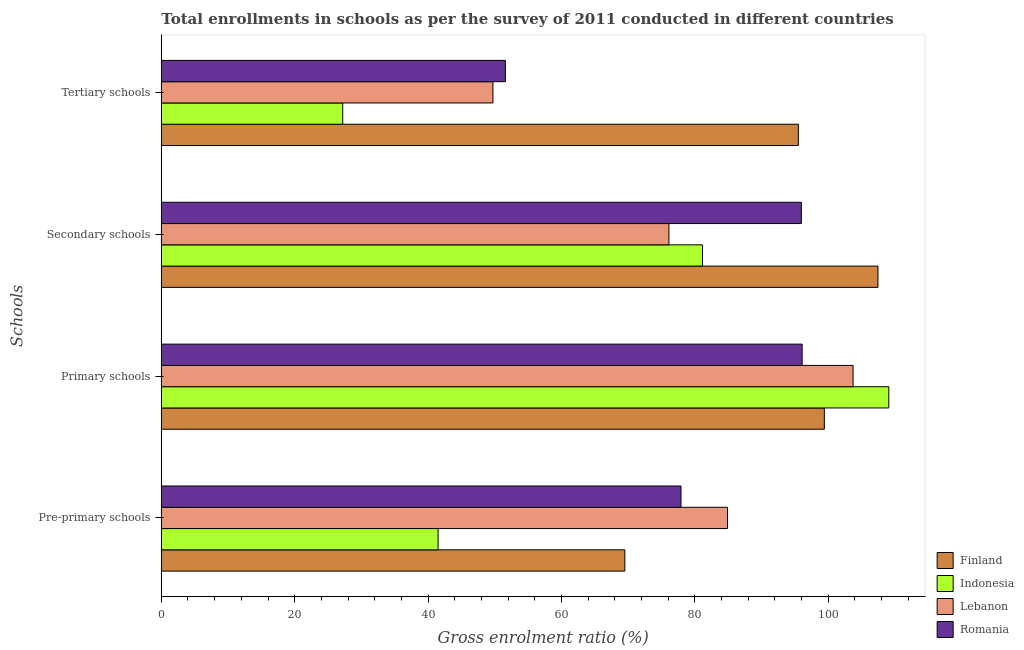Are the number of bars on each tick of the Y-axis equal?
Ensure brevity in your answer.  Yes. How many bars are there on the 4th tick from the top?
Keep it short and to the point. 4. What is the label of the 1st group of bars from the top?
Offer a terse response. Tertiary schools. What is the gross enrolment ratio in primary schools in Lebanon?
Keep it short and to the point. 103.74. Across all countries, what is the maximum gross enrolment ratio in pre-primary schools?
Keep it short and to the point. 84.92. Across all countries, what is the minimum gross enrolment ratio in secondary schools?
Provide a succinct answer. 76.13. In which country was the gross enrolment ratio in primary schools minimum?
Ensure brevity in your answer.  Romania. What is the total gross enrolment ratio in tertiary schools in the graph?
Offer a very short reply. 224.07. What is the difference between the gross enrolment ratio in tertiary schools in Indonesia and that in Lebanon?
Provide a short and direct response. -22.53. What is the difference between the gross enrolment ratio in primary schools in Indonesia and the gross enrolment ratio in secondary schools in Finland?
Offer a very short reply. 1.62. What is the average gross enrolment ratio in primary schools per country?
Make the answer very short. 102.1. What is the difference between the gross enrolment ratio in pre-primary schools and gross enrolment ratio in tertiary schools in Romania?
Your answer should be very brief. 26.34. What is the ratio of the gross enrolment ratio in secondary schools in Lebanon to that in Romania?
Your response must be concise. 0.79. Is the difference between the gross enrolment ratio in primary schools in Indonesia and Lebanon greater than the difference between the gross enrolment ratio in tertiary schools in Indonesia and Lebanon?
Make the answer very short. Yes. What is the difference between the highest and the second highest gross enrolment ratio in primary schools?
Your answer should be compact. 5.35. What is the difference between the highest and the lowest gross enrolment ratio in tertiary schools?
Offer a terse response. 68.33. Is it the case that in every country, the sum of the gross enrolment ratio in pre-primary schools and gross enrolment ratio in primary schools is greater than the sum of gross enrolment ratio in secondary schools and gross enrolment ratio in tertiary schools?
Keep it short and to the point. Yes. What does the 1st bar from the top in Secondary schools represents?
Make the answer very short. Romania. What does the 4th bar from the bottom in Primary schools represents?
Your answer should be very brief. Romania. Is it the case that in every country, the sum of the gross enrolment ratio in pre-primary schools and gross enrolment ratio in primary schools is greater than the gross enrolment ratio in secondary schools?
Your answer should be very brief. Yes. How many countries are there in the graph?
Provide a short and direct response. 4. Are the values on the major ticks of X-axis written in scientific E-notation?
Keep it short and to the point. No. Does the graph contain any zero values?
Your response must be concise. No. Does the graph contain grids?
Make the answer very short. No. Where does the legend appear in the graph?
Offer a terse response. Bottom right. How are the legend labels stacked?
Provide a succinct answer. Vertical. What is the title of the graph?
Make the answer very short. Total enrollments in schools as per the survey of 2011 conducted in different countries. What is the label or title of the Y-axis?
Your answer should be very brief. Schools. What is the Gross enrolment ratio (%) in Finland in Pre-primary schools?
Your answer should be compact. 69.52. What is the Gross enrolment ratio (%) of Indonesia in Pre-primary schools?
Provide a short and direct response. 41.51. What is the Gross enrolment ratio (%) in Lebanon in Pre-primary schools?
Provide a short and direct response. 84.92. What is the Gross enrolment ratio (%) in Romania in Pre-primary schools?
Provide a succinct answer. 77.94. What is the Gross enrolment ratio (%) in Finland in Primary schools?
Ensure brevity in your answer.  99.43. What is the Gross enrolment ratio (%) of Indonesia in Primary schools?
Your answer should be compact. 109.1. What is the Gross enrolment ratio (%) of Lebanon in Primary schools?
Make the answer very short. 103.74. What is the Gross enrolment ratio (%) of Romania in Primary schools?
Ensure brevity in your answer.  96.11. What is the Gross enrolment ratio (%) of Finland in Secondary schools?
Your answer should be compact. 107.48. What is the Gross enrolment ratio (%) of Indonesia in Secondary schools?
Offer a terse response. 81.16. What is the Gross enrolment ratio (%) in Lebanon in Secondary schools?
Keep it short and to the point. 76.13. What is the Gross enrolment ratio (%) of Romania in Secondary schools?
Keep it short and to the point. 95.99. What is the Gross enrolment ratio (%) in Finland in Tertiary schools?
Provide a short and direct response. 95.54. What is the Gross enrolment ratio (%) in Indonesia in Tertiary schools?
Give a very brief answer. 27.2. What is the Gross enrolment ratio (%) of Lebanon in Tertiary schools?
Ensure brevity in your answer.  49.73. What is the Gross enrolment ratio (%) in Romania in Tertiary schools?
Ensure brevity in your answer.  51.6. Across all Schools, what is the maximum Gross enrolment ratio (%) of Finland?
Your answer should be compact. 107.48. Across all Schools, what is the maximum Gross enrolment ratio (%) of Indonesia?
Make the answer very short. 109.1. Across all Schools, what is the maximum Gross enrolment ratio (%) in Lebanon?
Provide a succinct answer. 103.74. Across all Schools, what is the maximum Gross enrolment ratio (%) of Romania?
Your response must be concise. 96.11. Across all Schools, what is the minimum Gross enrolment ratio (%) in Finland?
Your answer should be very brief. 69.52. Across all Schools, what is the minimum Gross enrolment ratio (%) of Indonesia?
Offer a very short reply. 27.2. Across all Schools, what is the minimum Gross enrolment ratio (%) of Lebanon?
Ensure brevity in your answer.  49.73. Across all Schools, what is the minimum Gross enrolment ratio (%) of Romania?
Your answer should be compact. 51.6. What is the total Gross enrolment ratio (%) of Finland in the graph?
Keep it short and to the point. 371.97. What is the total Gross enrolment ratio (%) of Indonesia in the graph?
Make the answer very short. 258.97. What is the total Gross enrolment ratio (%) of Lebanon in the graph?
Provide a short and direct response. 314.52. What is the total Gross enrolment ratio (%) of Romania in the graph?
Offer a terse response. 321.62. What is the difference between the Gross enrolment ratio (%) in Finland in Pre-primary schools and that in Primary schools?
Provide a succinct answer. -29.92. What is the difference between the Gross enrolment ratio (%) in Indonesia in Pre-primary schools and that in Primary schools?
Your answer should be compact. -67.59. What is the difference between the Gross enrolment ratio (%) of Lebanon in Pre-primary schools and that in Primary schools?
Offer a very short reply. -18.83. What is the difference between the Gross enrolment ratio (%) in Romania in Pre-primary schools and that in Primary schools?
Make the answer very short. -18.17. What is the difference between the Gross enrolment ratio (%) of Finland in Pre-primary schools and that in Secondary schools?
Offer a very short reply. -37.96. What is the difference between the Gross enrolment ratio (%) of Indonesia in Pre-primary schools and that in Secondary schools?
Your answer should be very brief. -39.65. What is the difference between the Gross enrolment ratio (%) of Lebanon in Pre-primary schools and that in Secondary schools?
Make the answer very short. 8.79. What is the difference between the Gross enrolment ratio (%) of Romania in Pre-primary schools and that in Secondary schools?
Your answer should be compact. -18.05. What is the difference between the Gross enrolment ratio (%) in Finland in Pre-primary schools and that in Tertiary schools?
Your response must be concise. -26.02. What is the difference between the Gross enrolment ratio (%) in Indonesia in Pre-primary schools and that in Tertiary schools?
Your answer should be very brief. 14.3. What is the difference between the Gross enrolment ratio (%) in Lebanon in Pre-primary schools and that in Tertiary schools?
Keep it short and to the point. 35.18. What is the difference between the Gross enrolment ratio (%) in Romania in Pre-primary schools and that in Tertiary schools?
Ensure brevity in your answer.  26.34. What is the difference between the Gross enrolment ratio (%) in Finland in Primary schools and that in Secondary schools?
Your response must be concise. -8.04. What is the difference between the Gross enrolment ratio (%) in Indonesia in Primary schools and that in Secondary schools?
Provide a succinct answer. 27.94. What is the difference between the Gross enrolment ratio (%) in Lebanon in Primary schools and that in Secondary schools?
Ensure brevity in your answer.  27.62. What is the difference between the Gross enrolment ratio (%) of Romania in Primary schools and that in Secondary schools?
Provide a short and direct response. 0.12. What is the difference between the Gross enrolment ratio (%) of Finland in Primary schools and that in Tertiary schools?
Offer a terse response. 3.9. What is the difference between the Gross enrolment ratio (%) of Indonesia in Primary schools and that in Tertiary schools?
Give a very brief answer. 81.89. What is the difference between the Gross enrolment ratio (%) in Lebanon in Primary schools and that in Tertiary schools?
Provide a succinct answer. 54.01. What is the difference between the Gross enrolment ratio (%) in Romania in Primary schools and that in Tertiary schools?
Offer a terse response. 44.51. What is the difference between the Gross enrolment ratio (%) of Finland in Secondary schools and that in Tertiary schools?
Make the answer very short. 11.94. What is the difference between the Gross enrolment ratio (%) of Indonesia in Secondary schools and that in Tertiary schools?
Ensure brevity in your answer.  53.96. What is the difference between the Gross enrolment ratio (%) of Lebanon in Secondary schools and that in Tertiary schools?
Ensure brevity in your answer.  26.39. What is the difference between the Gross enrolment ratio (%) of Romania in Secondary schools and that in Tertiary schools?
Give a very brief answer. 44.39. What is the difference between the Gross enrolment ratio (%) of Finland in Pre-primary schools and the Gross enrolment ratio (%) of Indonesia in Primary schools?
Offer a terse response. -39.58. What is the difference between the Gross enrolment ratio (%) in Finland in Pre-primary schools and the Gross enrolment ratio (%) in Lebanon in Primary schools?
Offer a very short reply. -34.23. What is the difference between the Gross enrolment ratio (%) in Finland in Pre-primary schools and the Gross enrolment ratio (%) in Romania in Primary schools?
Give a very brief answer. -26.59. What is the difference between the Gross enrolment ratio (%) of Indonesia in Pre-primary schools and the Gross enrolment ratio (%) of Lebanon in Primary schools?
Give a very brief answer. -62.24. What is the difference between the Gross enrolment ratio (%) in Indonesia in Pre-primary schools and the Gross enrolment ratio (%) in Romania in Primary schools?
Your response must be concise. -54.6. What is the difference between the Gross enrolment ratio (%) of Lebanon in Pre-primary schools and the Gross enrolment ratio (%) of Romania in Primary schools?
Your response must be concise. -11.19. What is the difference between the Gross enrolment ratio (%) in Finland in Pre-primary schools and the Gross enrolment ratio (%) in Indonesia in Secondary schools?
Make the answer very short. -11.65. What is the difference between the Gross enrolment ratio (%) of Finland in Pre-primary schools and the Gross enrolment ratio (%) of Lebanon in Secondary schools?
Offer a terse response. -6.61. What is the difference between the Gross enrolment ratio (%) of Finland in Pre-primary schools and the Gross enrolment ratio (%) of Romania in Secondary schools?
Keep it short and to the point. -26.47. What is the difference between the Gross enrolment ratio (%) in Indonesia in Pre-primary schools and the Gross enrolment ratio (%) in Lebanon in Secondary schools?
Offer a very short reply. -34.62. What is the difference between the Gross enrolment ratio (%) in Indonesia in Pre-primary schools and the Gross enrolment ratio (%) in Romania in Secondary schools?
Offer a terse response. -54.48. What is the difference between the Gross enrolment ratio (%) in Lebanon in Pre-primary schools and the Gross enrolment ratio (%) in Romania in Secondary schools?
Your answer should be compact. -11.07. What is the difference between the Gross enrolment ratio (%) in Finland in Pre-primary schools and the Gross enrolment ratio (%) in Indonesia in Tertiary schools?
Provide a succinct answer. 42.31. What is the difference between the Gross enrolment ratio (%) of Finland in Pre-primary schools and the Gross enrolment ratio (%) of Lebanon in Tertiary schools?
Your answer should be compact. 19.78. What is the difference between the Gross enrolment ratio (%) of Finland in Pre-primary schools and the Gross enrolment ratio (%) of Romania in Tertiary schools?
Offer a very short reply. 17.92. What is the difference between the Gross enrolment ratio (%) in Indonesia in Pre-primary schools and the Gross enrolment ratio (%) in Lebanon in Tertiary schools?
Your response must be concise. -8.23. What is the difference between the Gross enrolment ratio (%) of Indonesia in Pre-primary schools and the Gross enrolment ratio (%) of Romania in Tertiary schools?
Make the answer very short. -10.09. What is the difference between the Gross enrolment ratio (%) of Lebanon in Pre-primary schools and the Gross enrolment ratio (%) of Romania in Tertiary schools?
Your answer should be very brief. 33.32. What is the difference between the Gross enrolment ratio (%) in Finland in Primary schools and the Gross enrolment ratio (%) in Indonesia in Secondary schools?
Give a very brief answer. 18.27. What is the difference between the Gross enrolment ratio (%) in Finland in Primary schools and the Gross enrolment ratio (%) in Lebanon in Secondary schools?
Make the answer very short. 23.31. What is the difference between the Gross enrolment ratio (%) of Finland in Primary schools and the Gross enrolment ratio (%) of Romania in Secondary schools?
Offer a terse response. 3.45. What is the difference between the Gross enrolment ratio (%) of Indonesia in Primary schools and the Gross enrolment ratio (%) of Lebanon in Secondary schools?
Offer a very short reply. 32.97. What is the difference between the Gross enrolment ratio (%) of Indonesia in Primary schools and the Gross enrolment ratio (%) of Romania in Secondary schools?
Ensure brevity in your answer.  13.11. What is the difference between the Gross enrolment ratio (%) in Lebanon in Primary schools and the Gross enrolment ratio (%) in Romania in Secondary schools?
Your answer should be compact. 7.76. What is the difference between the Gross enrolment ratio (%) of Finland in Primary schools and the Gross enrolment ratio (%) of Indonesia in Tertiary schools?
Offer a very short reply. 72.23. What is the difference between the Gross enrolment ratio (%) of Finland in Primary schools and the Gross enrolment ratio (%) of Lebanon in Tertiary schools?
Offer a terse response. 49.7. What is the difference between the Gross enrolment ratio (%) of Finland in Primary schools and the Gross enrolment ratio (%) of Romania in Tertiary schools?
Ensure brevity in your answer.  47.84. What is the difference between the Gross enrolment ratio (%) of Indonesia in Primary schools and the Gross enrolment ratio (%) of Lebanon in Tertiary schools?
Your answer should be very brief. 59.36. What is the difference between the Gross enrolment ratio (%) in Indonesia in Primary schools and the Gross enrolment ratio (%) in Romania in Tertiary schools?
Ensure brevity in your answer.  57.5. What is the difference between the Gross enrolment ratio (%) in Lebanon in Primary schools and the Gross enrolment ratio (%) in Romania in Tertiary schools?
Your answer should be very brief. 52.15. What is the difference between the Gross enrolment ratio (%) in Finland in Secondary schools and the Gross enrolment ratio (%) in Indonesia in Tertiary schools?
Provide a succinct answer. 80.27. What is the difference between the Gross enrolment ratio (%) of Finland in Secondary schools and the Gross enrolment ratio (%) of Lebanon in Tertiary schools?
Keep it short and to the point. 57.74. What is the difference between the Gross enrolment ratio (%) in Finland in Secondary schools and the Gross enrolment ratio (%) in Romania in Tertiary schools?
Offer a terse response. 55.88. What is the difference between the Gross enrolment ratio (%) of Indonesia in Secondary schools and the Gross enrolment ratio (%) of Lebanon in Tertiary schools?
Your response must be concise. 31.43. What is the difference between the Gross enrolment ratio (%) of Indonesia in Secondary schools and the Gross enrolment ratio (%) of Romania in Tertiary schools?
Offer a very short reply. 29.57. What is the difference between the Gross enrolment ratio (%) of Lebanon in Secondary schools and the Gross enrolment ratio (%) of Romania in Tertiary schools?
Provide a succinct answer. 24.53. What is the average Gross enrolment ratio (%) of Finland per Schools?
Keep it short and to the point. 92.99. What is the average Gross enrolment ratio (%) of Indonesia per Schools?
Give a very brief answer. 64.74. What is the average Gross enrolment ratio (%) of Lebanon per Schools?
Offer a terse response. 78.63. What is the average Gross enrolment ratio (%) in Romania per Schools?
Your answer should be compact. 80.41. What is the difference between the Gross enrolment ratio (%) of Finland and Gross enrolment ratio (%) of Indonesia in Pre-primary schools?
Make the answer very short. 28.01. What is the difference between the Gross enrolment ratio (%) of Finland and Gross enrolment ratio (%) of Lebanon in Pre-primary schools?
Offer a very short reply. -15.4. What is the difference between the Gross enrolment ratio (%) in Finland and Gross enrolment ratio (%) in Romania in Pre-primary schools?
Your answer should be compact. -8.42. What is the difference between the Gross enrolment ratio (%) of Indonesia and Gross enrolment ratio (%) of Lebanon in Pre-primary schools?
Give a very brief answer. -43.41. What is the difference between the Gross enrolment ratio (%) of Indonesia and Gross enrolment ratio (%) of Romania in Pre-primary schools?
Provide a succinct answer. -36.43. What is the difference between the Gross enrolment ratio (%) of Lebanon and Gross enrolment ratio (%) of Romania in Pre-primary schools?
Your answer should be compact. 6.98. What is the difference between the Gross enrolment ratio (%) in Finland and Gross enrolment ratio (%) in Indonesia in Primary schools?
Ensure brevity in your answer.  -9.66. What is the difference between the Gross enrolment ratio (%) of Finland and Gross enrolment ratio (%) of Lebanon in Primary schools?
Make the answer very short. -4.31. What is the difference between the Gross enrolment ratio (%) in Finland and Gross enrolment ratio (%) in Romania in Primary schools?
Give a very brief answer. 3.33. What is the difference between the Gross enrolment ratio (%) in Indonesia and Gross enrolment ratio (%) in Lebanon in Primary schools?
Make the answer very short. 5.35. What is the difference between the Gross enrolment ratio (%) in Indonesia and Gross enrolment ratio (%) in Romania in Primary schools?
Offer a terse response. 12.99. What is the difference between the Gross enrolment ratio (%) of Lebanon and Gross enrolment ratio (%) of Romania in Primary schools?
Give a very brief answer. 7.64. What is the difference between the Gross enrolment ratio (%) in Finland and Gross enrolment ratio (%) in Indonesia in Secondary schools?
Give a very brief answer. 26.32. What is the difference between the Gross enrolment ratio (%) of Finland and Gross enrolment ratio (%) of Lebanon in Secondary schools?
Your answer should be very brief. 31.35. What is the difference between the Gross enrolment ratio (%) of Finland and Gross enrolment ratio (%) of Romania in Secondary schools?
Your answer should be compact. 11.49. What is the difference between the Gross enrolment ratio (%) in Indonesia and Gross enrolment ratio (%) in Lebanon in Secondary schools?
Your answer should be very brief. 5.03. What is the difference between the Gross enrolment ratio (%) in Indonesia and Gross enrolment ratio (%) in Romania in Secondary schools?
Your answer should be very brief. -14.82. What is the difference between the Gross enrolment ratio (%) of Lebanon and Gross enrolment ratio (%) of Romania in Secondary schools?
Offer a terse response. -19.86. What is the difference between the Gross enrolment ratio (%) of Finland and Gross enrolment ratio (%) of Indonesia in Tertiary schools?
Give a very brief answer. 68.33. What is the difference between the Gross enrolment ratio (%) in Finland and Gross enrolment ratio (%) in Lebanon in Tertiary schools?
Your answer should be compact. 45.8. What is the difference between the Gross enrolment ratio (%) in Finland and Gross enrolment ratio (%) in Romania in Tertiary schools?
Ensure brevity in your answer.  43.94. What is the difference between the Gross enrolment ratio (%) of Indonesia and Gross enrolment ratio (%) of Lebanon in Tertiary schools?
Your response must be concise. -22.53. What is the difference between the Gross enrolment ratio (%) of Indonesia and Gross enrolment ratio (%) of Romania in Tertiary schools?
Offer a very short reply. -24.39. What is the difference between the Gross enrolment ratio (%) in Lebanon and Gross enrolment ratio (%) in Romania in Tertiary schools?
Provide a short and direct response. -1.86. What is the ratio of the Gross enrolment ratio (%) in Finland in Pre-primary schools to that in Primary schools?
Your answer should be compact. 0.7. What is the ratio of the Gross enrolment ratio (%) of Indonesia in Pre-primary schools to that in Primary schools?
Provide a succinct answer. 0.38. What is the ratio of the Gross enrolment ratio (%) in Lebanon in Pre-primary schools to that in Primary schools?
Give a very brief answer. 0.82. What is the ratio of the Gross enrolment ratio (%) in Romania in Pre-primary schools to that in Primary schools?
Your response must be concise. 0.81. What is the ratio of the Gross enrolment ratio (%) in Finland in Pre-primary schools to that in Secondary schools?
Ensure brevity in your answer.  0.65. What is the ratio of the Gross enrolment ratio (%) of Indonesia in Pre-primary schools to that in Secondary schools?
Offer a terse response. 0.51. What is the ratio of the Gross enrolment ratio (%) of Lebanon in Pre-primary schools to that in Secondary schools?
Your answer should be compact. 1.12. What is the ratio of the Gross enrolment ratio (%) in Romania in Pre-primary schools to that in Secondary schools?
Give a very brief answer. 0.81. What is the ratio of the Gross enrolment ratio (%) in Finland in Pre-primary schools to that in Tertiary schools?
Provide a succinct answer. 0.73. What is the ratio of the Gross enrolment ratio (%) in Indonesia in Pre-primary schools to that in Tertiary schools?
Your answer should be compact. 1.53. What is the ratio of the Gross enrolment ratio (%) in Lebanon in Pre-primary schools to that in Tertiary schools?
Provide a succinct answer. 1.71. What is the ratio of the Gross enrolment ratio (%) in Romania in Pre-primary schools to that in Tertiary schools?
Offer a terse response. 1.51. What is the ratio of the Gross enrolment ratio (%) of Finland in Primary schools to that in Secondary schools?
Give a very brief answer. 0.93. What is the ratio of the Gross enrolment ratio (%) in Indonesia in Primary schools to that in Secondary schools?
Offer a very short reply. 1.34. What is the ratio of the Gross enrolment ratio (%) in Lebanon in Primary schools to that in Secondary schools?
Ensure brevity in your answer.  1.36. What is the ratio of the Gross enrolment ratio (%) in Finland in Primary schools to that in Tertiary schools?
Your answer should be very brief. 1.04. What is the ratio of the Gross enrolment ratio (%) of Indonesia in Primary schools to that in Tertiary schools?
Your response must be concise. 4.01. What is the ratio of the Gross enrolment ratio (%) of Lebanon in Primary schools to that in Tertiary schools?
Your response must be concise. 2.09. What is the ratio of the Gross enrolment ratio (%) of Romania in Primary schools to that in Tertiary schools?
Keep it short and to the point. 1.86. What is the ratio of the Gross enrolment ratio (%) of Finland in Secondary schools to that in Tertiary schools?
Your response must be concise. 1.12. What is the ratio of the Gross enrolment ratio (%) in Indonesia in Secondary schools to that in Tertiary schools?
Your response must be concise. 2.98. What is the ratio of the Gross enrolment ratio (%) in Lebanon in Secondary schools to that in Tertiary schools?
Your answer should be very brief. 1.53. What is the ratio of the Gross enrolment ratio (%) of Romania in Secondary schools to that in Tertiary schools?
Your response must be concise. 1.86. What is the difference between the highest and the second highest Gross enrolment ratio (%) of Finland?
Your answer should be very brief. 8.04. What is the difference between the highest and the second highest Gross enrolment ratio (%) in Indonesia?
Your response must be concise. 27.94. What is the difference between the highest and the second highest Gross enrolment ratio (%) of Lebanon?
Offer a very short reply. 18.83. What is the difference between the highest and the second highest Gross enrolment ratio (%) in Romania?
Your response must be concise. 0.12. What is the difference between the highest and the lowest Gross enrolment ratio (%) in Finland?
Your response must be concise. 37.96. What is the difference between the highest and the lowest Gross enrolment ratio (%) in Indonesia?
Ensure brevity in your answer.  81.89. What is the difference between the highest and the lowest Gross enrolment ratio (%) in Lebanon?
Offer a very short reply. 54.01. What is the difference between the highest and the lowest Gross enrolment ratio (%) of Romania?
Your response must be concise. 44.51. 